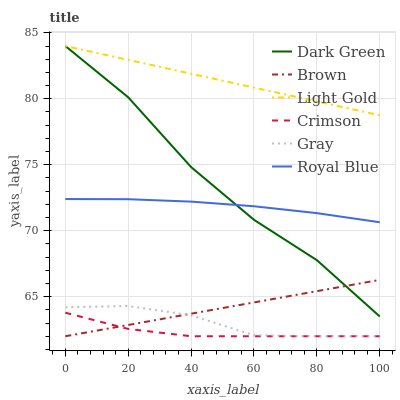Does Crimson have the minimum area under the curve?
Answer yes or no. Yes. Does Light Gold have the maximum area under the curve?
Answer yes or no. Yes. Does Gray have the minimum area under the curve?
Answer yes or no. No. Does Gray have the maximum area under the curve?
Answer yes or no. No. Is Brown the smoothest?
Answer yes or no. Yes. Is Dark Green the roughest?
Answer yes or no. Yes. Is Gray the smoothest?
Answer yes or no. No. Is Gray the roughest?
Answer yes or no. No. Does Brown have the lowest value?
Answer yes or no. Yes. Does Royal Blue have the lowest value?
Answer yes or no. No. Does Dark Green have the highest value?
Answer yes or no. Yes. Does Gray have the highest value?
Answer yes or no. No. Is Gray less than Dark Green?
Answer yes or no. Yes. Is Light Gold greater than Crimson?
Answer yes or no. Yes. Does Gray intersect Brown?
Answer yes or no. Yes. Is Gray less than Brown?
Answer yes or no. No. Is Gray greater than Brown?
Answer yes or no. No. Does Gray intersect Dark Green?
Answer yes or no. No. 